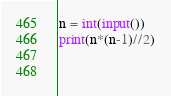<code> <loc_0><loc_0><loc_500><loc_500><_Python_>n = int(input())
print(n*(n-1)//2)
    
  </code> 